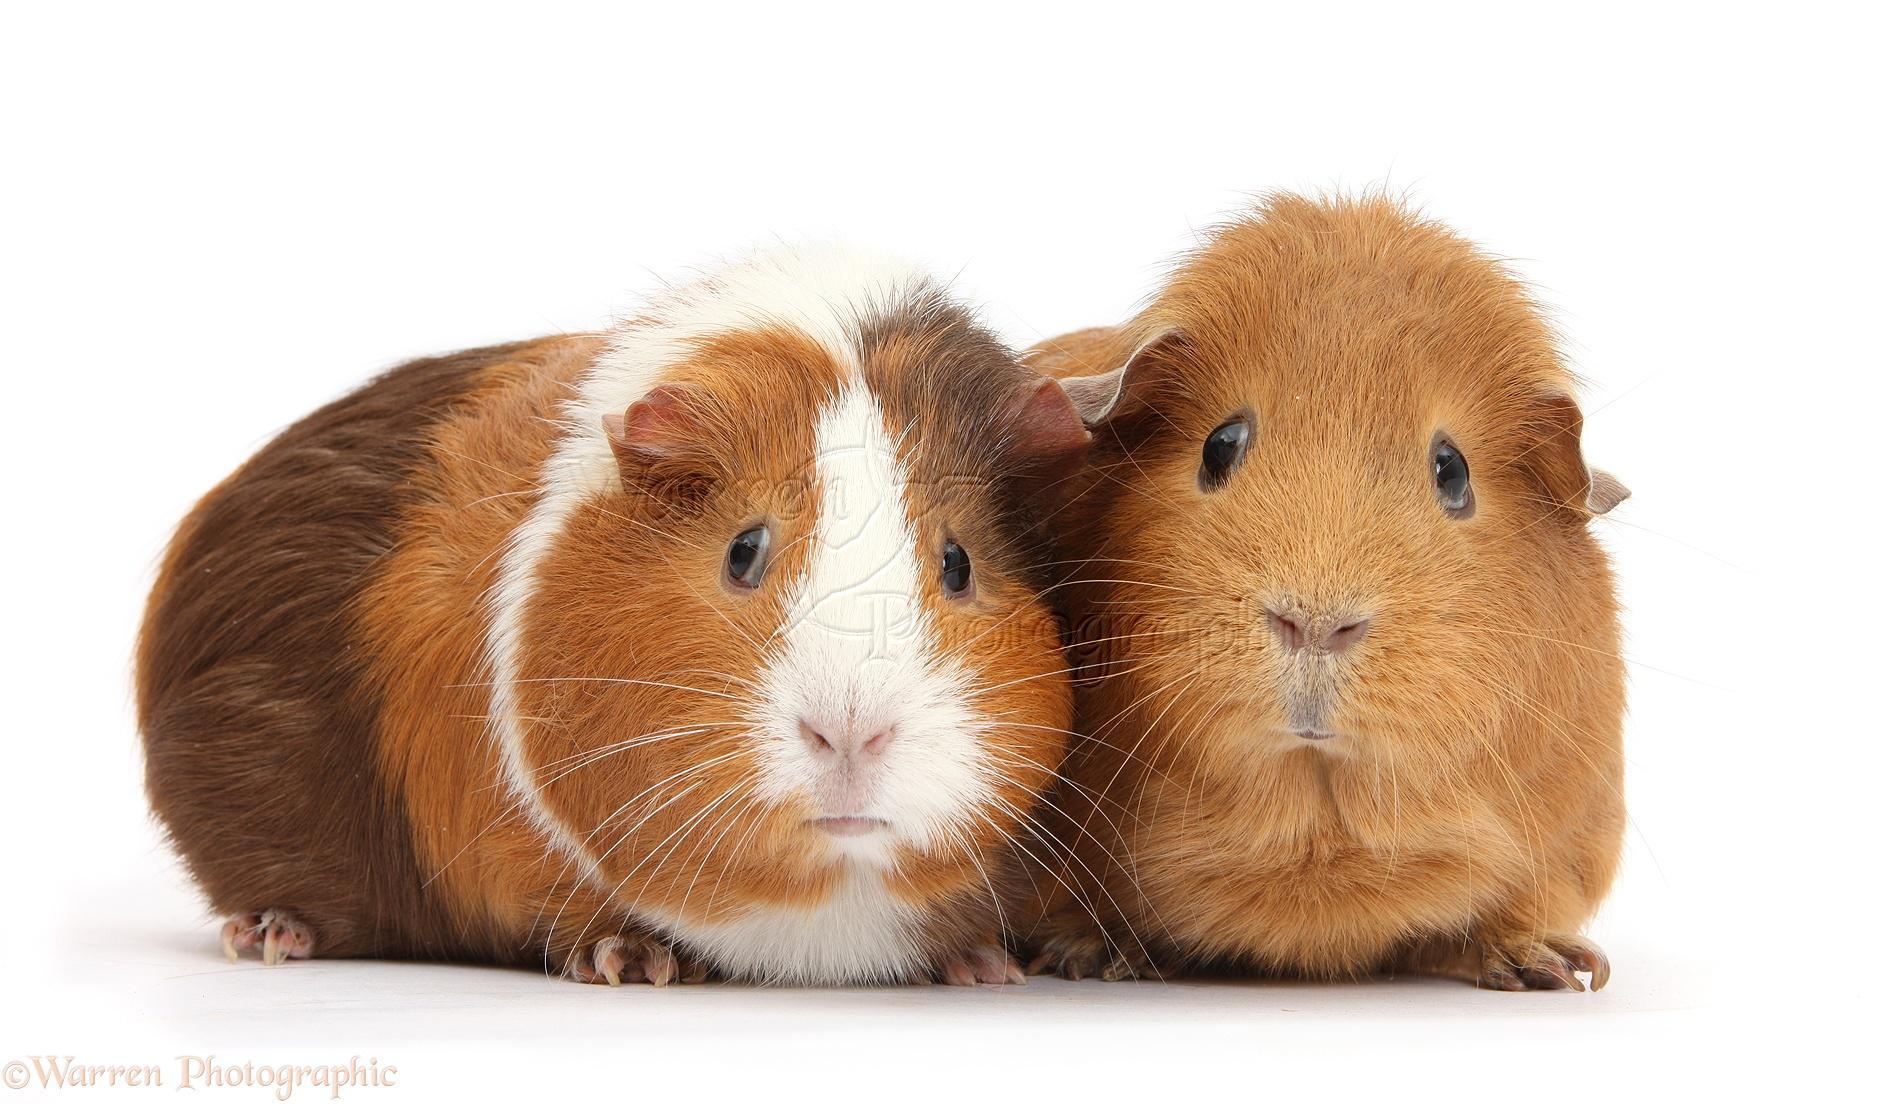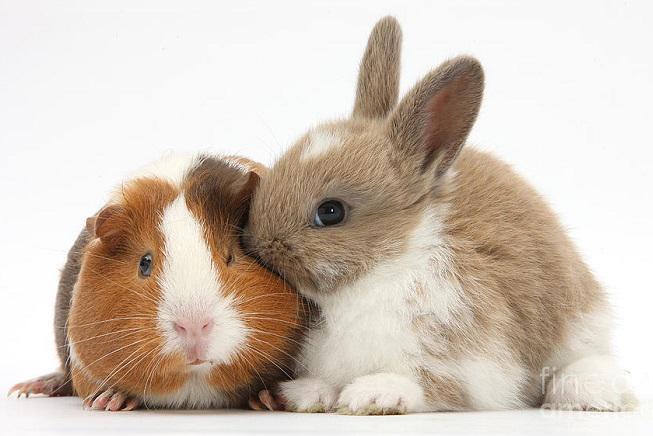The first image is the image on the left, the second image is the image on the right. Analyze the images presented: Is the assertion "All of the animals are a type of guinea pig and none of them are sitting on top of each other." valid? Answer yes or no. No. The first image is the image on the left, the second image is the image on the right. Examine the images to the left and right. Is the description "The right image has three guinea pigs." accurate? Answer yes or no. No. 